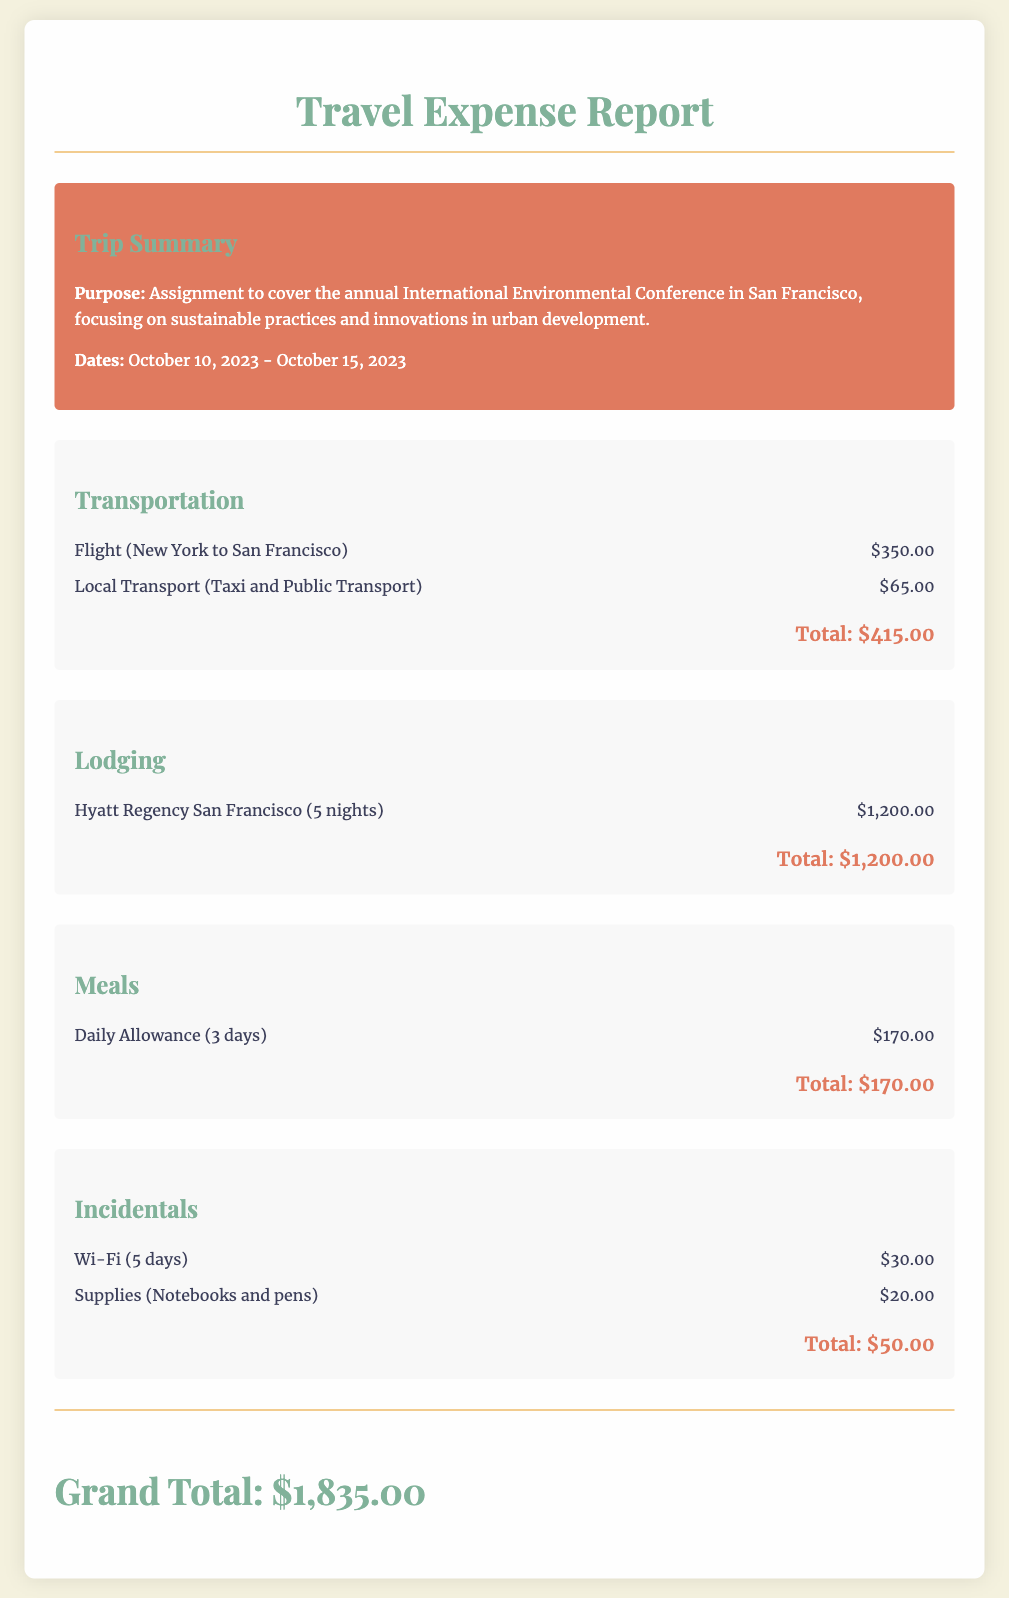What was the purpose of the trip? The purpose of the trip is detailed in the summary section, mentioning it was for an assignment to cover the annual International Environmental Conference.
Answer: Assignment to cover the annual International Environmental Conference What are the dates of the trip? The dates of the trip are specified in the summary, indicating it took place from October 10, 2023, to October 15, 2023.
Answer: October 10, 2023 - October 15, 2023 How much was spent on lodging? The total for lodging is listed in the lodging section, showing a cost of $1,200.
Answer: $1,200.00 What is the total for incidentals? The total for incidentals is calculated at the end of the incidentals section, which sums to $50.
Answer: $50.00 What was the total transportation cost? The total transportation cost is provided at the end of the transportation section, amounting to $415.
Answer: $415.00 How many nights was lodging booked? The lodging section specifies that lodging was booked for 5 nights at the Hyatt Regency.
Answer: 5 nights What is the grand total of the expenses? The grand total is presented at the bottom of the report, summarizing all expenses amounting to $1,835.
Answer: $1,835.00 How much was allocated for meals? The meal expenses total is provided in the meals section, stating it was $170.
Answer: $170.00 What type of document is this? This document is specifically a travel expense report, as indicated by the title at the top.
Answer: Travel Expense Report 